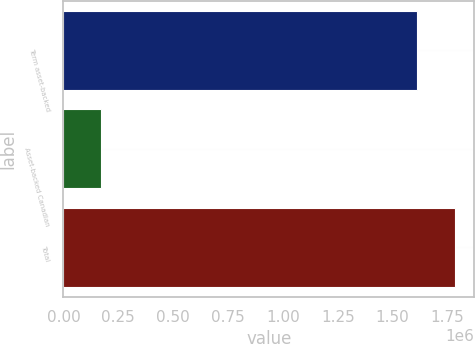Convert chart. <chart><loc_0><loc_0><loc_500><loc_500><bar_chart><fcel>Term asset-backed<fcel>Asset-backed Canadian<fcel>Total<nl><fcel>1.61162e+06<fcel>170708<fcel>1.78233e+06<nl></chart> 